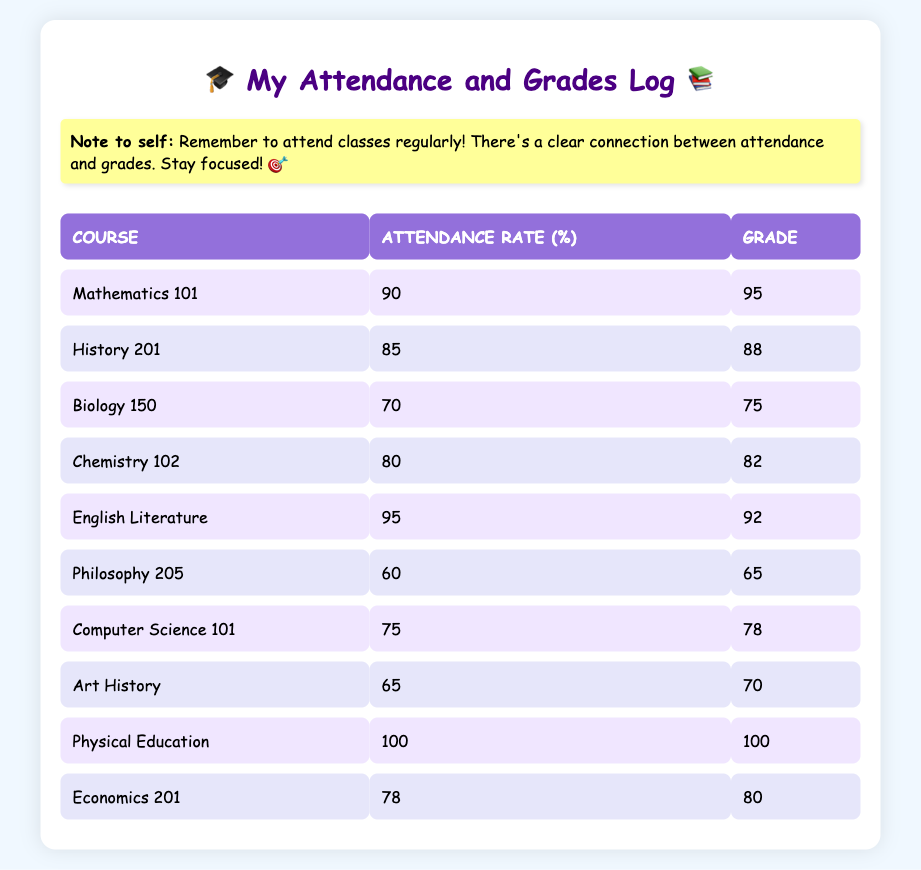What is the attendance rate for Mathematics 101? The attendance rate for Mathematics 101 is listed directly in the table under the attendance rate column next to the course name. The value is 90%.
Answer: 90% What grade did students achieve in Physical Education? The grade for Physical Education can be found in the table under the grade column corresponding to the course name. It shows a grade of 100.
Answer: 100 Is the attendance rate for Philosophy 205 higher than that for Biology 150? The attendance rate for Philosophy 205 is 60%, and for Biology 150, it is 70%. Since 60% is not higher than 70%, the answer is no.
Answer: No What is the average attendance rate across all courses? To calculate the average attendance rate, we sum the attendance rates: (90 + 85 + 70 + 80 + 95 + 60 + 75 + 65 + 100 + 78) =  88.5. Since there are 10 courses, we divide the sum by 10 to get the average: 885 / 10 = 88.5%.
Answer: 88.5% Which course had the lowest grade, and what was it? We need to identify the lowest grade from the grade column in the table. Scanning through, the grades show that Philosophy 205, with a grade of 65, is the lowest.
Answer: Philosophy 205, 65 What is the difference in grades between English Literature and Chemistry 102? The grade for English Literature is 92, and the grade for Chemistry 102 is 82. To find the difference, we subtract 82 from 92: 92 - 82 = 10.
Answer: 10 Which course has the highest attendance rate? The attendance rates are 90, 85, 70, 80, 95, 60, 75, 65, 100, and 78. The highest value is 100% for Physical Education.
Answer: Physical Education If a student has an attendance rate of 78%, what grade can they expect based on the table data? Looking at the attendance rates, those with 78% are in the category of Economics 201, which has a grade of 80. So, a student with a 78% attendance rate can expect a grade of around 80.
Answer: 80 How many courses have an attendance rate of less than 80%? Examining the attendance rates: 70 (Biology 150), 60 (Philosophy 205), 75 (Computer Science 101), 65 (Art History) all fall below 80%. There are 4 such courses.
Answer: 4 